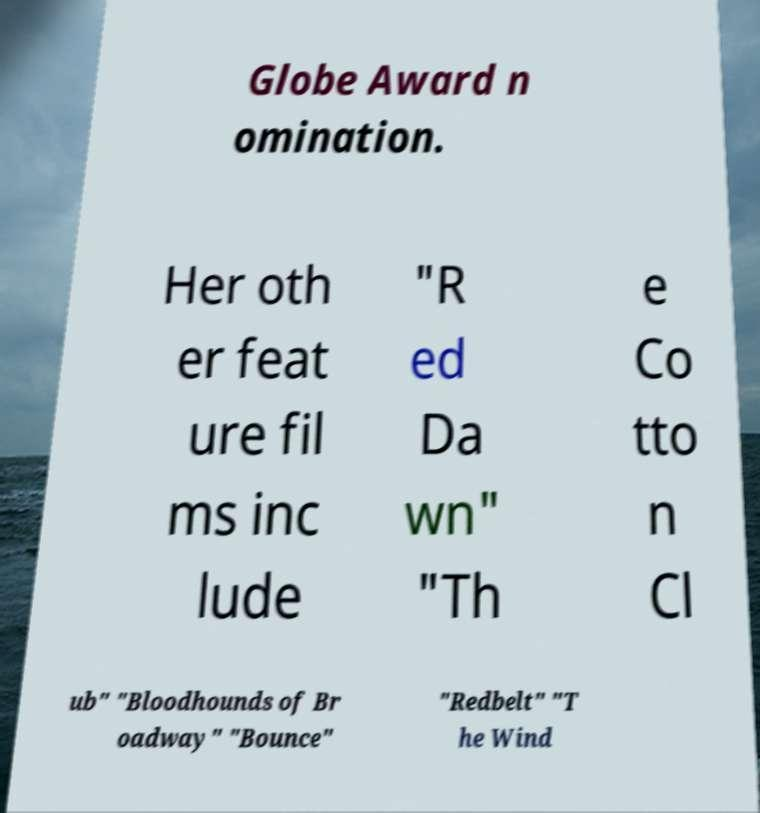I need the written content from this picture converted into text. Can you do that? Globe Award n omination. Her oth er feat ure fil ms inc lude "R ed Da wn" "Th e Co tto n Cl ub" "Bloodhounds of Br oadway" "Bounce" "Redbelt" "T he Wind 